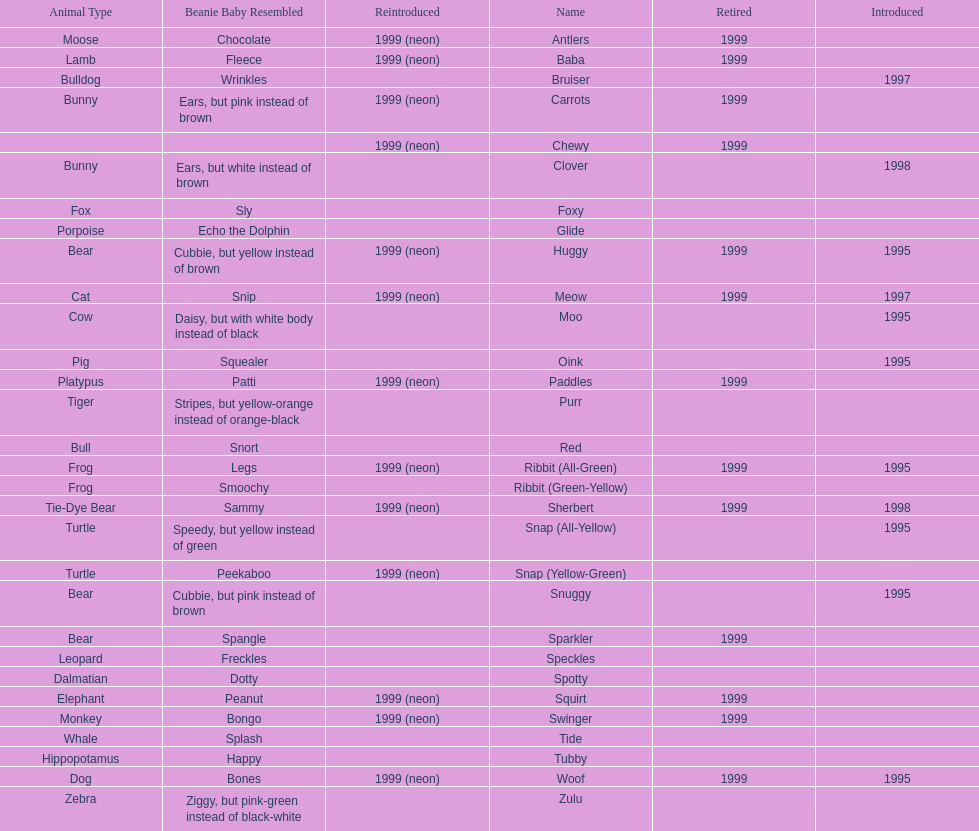In what year were the first pillow pals introduced? 1995. 